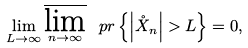<formula> <loc_0><loc_0><loc_500><loc_500>\lim _ { L \rightarrow \infty } \varlimsup _ { n \rightarrow \infty } \ p r \left \{ \left | \mathring { X } _ { n } \right | > L \right \} = 0 ,</formula> 